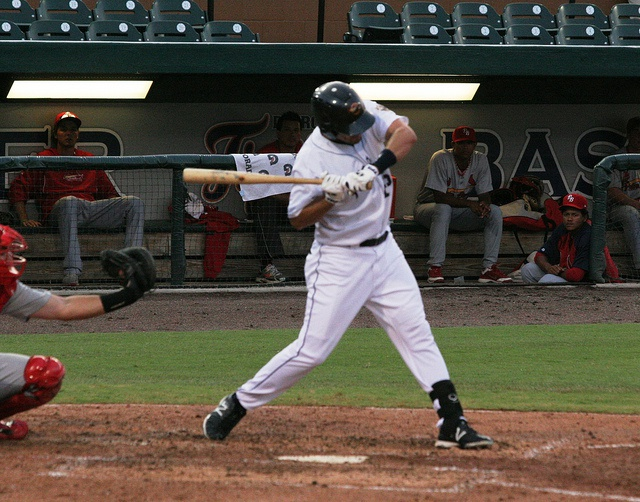Describe the objects in this image and their specific colors. I can see people in navy, lavender, black, darkgray, and gray tones, people in navy, black, gray, maroon, and purple tones, people in navy, black, gray, purple, and maroon tones, chair in navy, black, gray, and purple tones, and people in navy, black, maroon, gray, and brown tones in this image. 